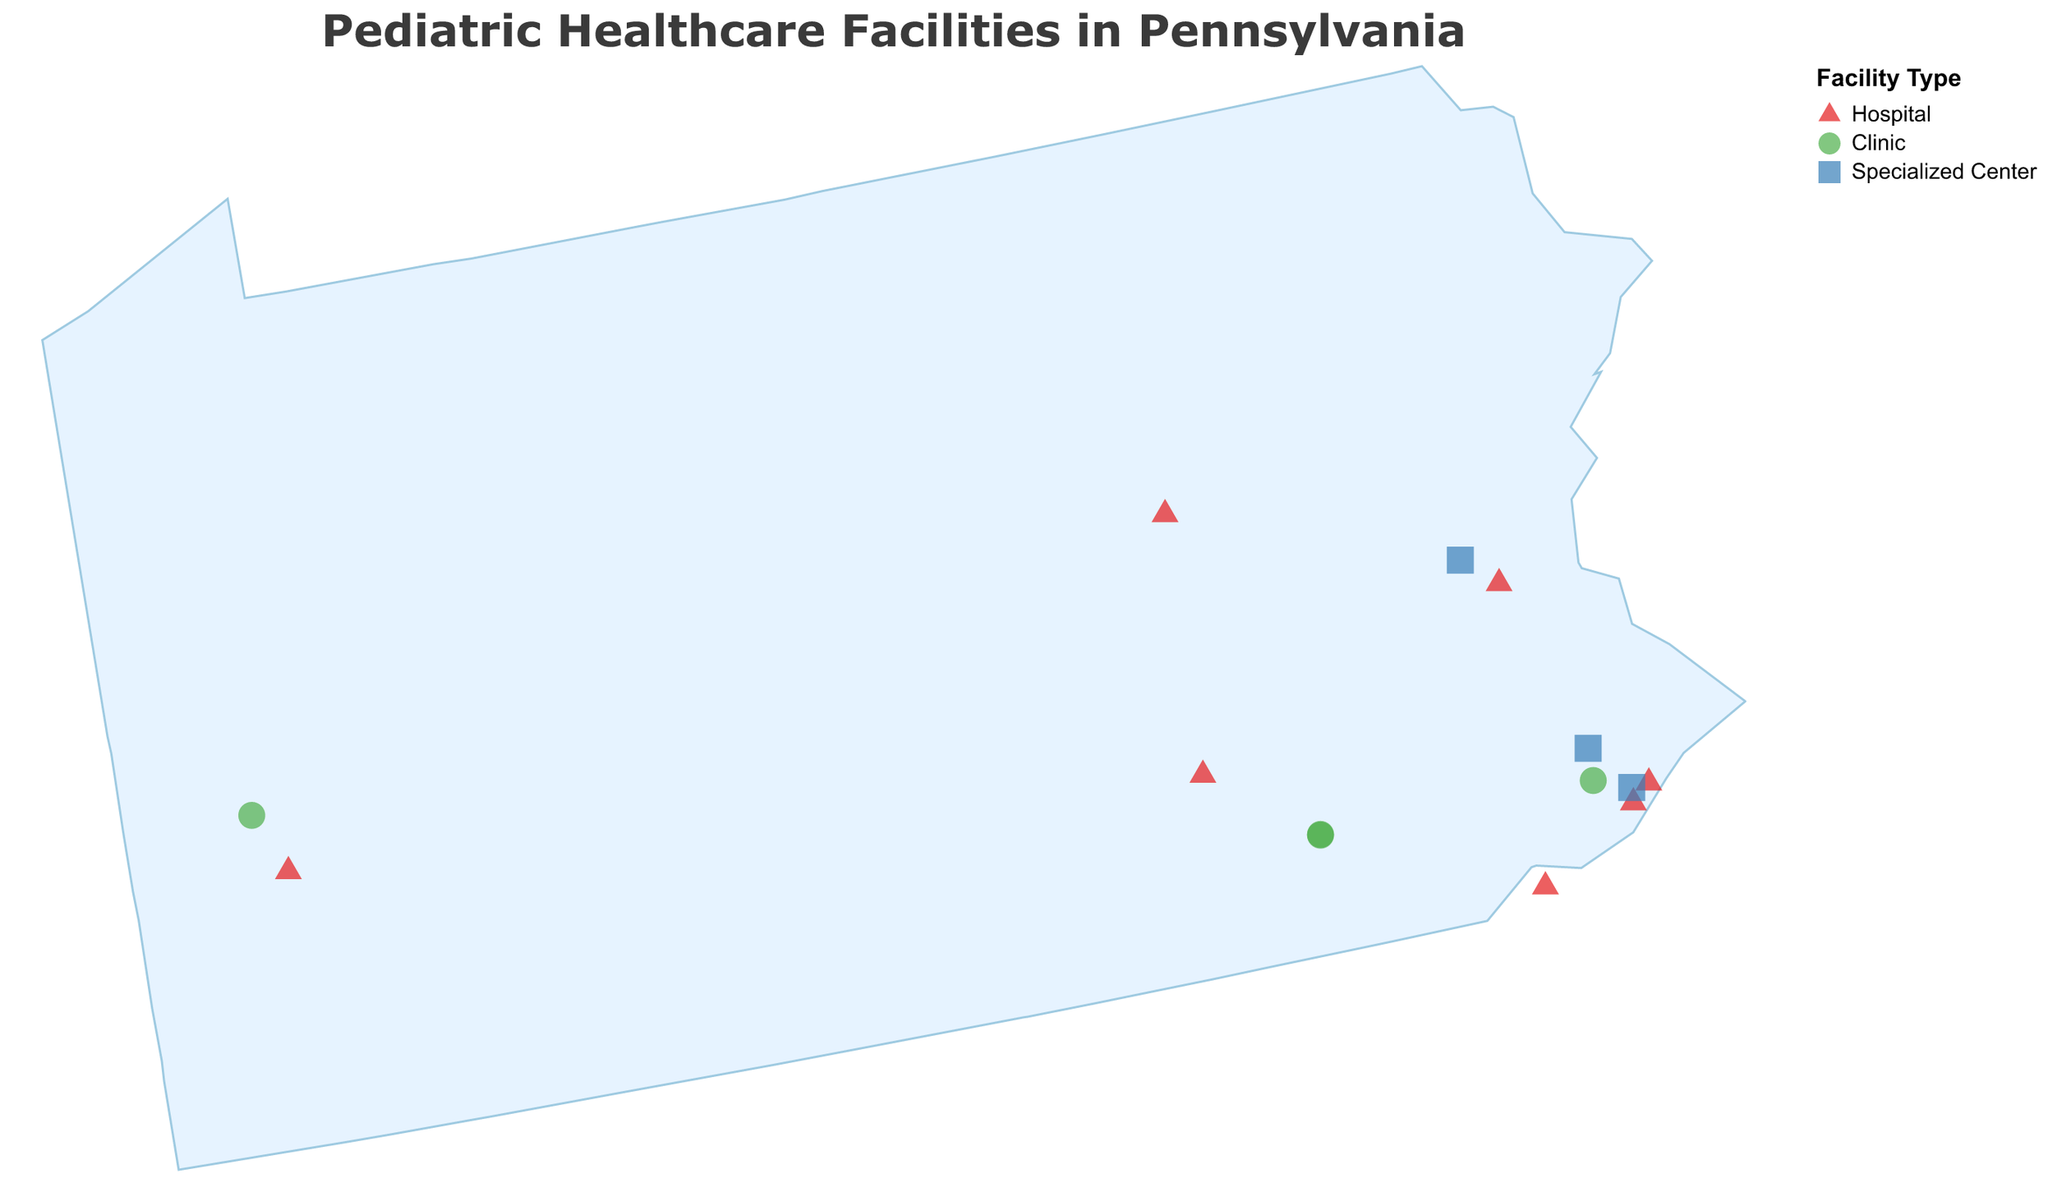How many different types of pediatric healthcare facilities are shown in the plot? The plot legend shows three different facility types: Hospital, Clinic, and Specialized Center.
Answer: 3 What is the most common specialty among the facilities in the plot? By looking at the tooltip or dataset, we see that "Comprehensive" is the most frequent specialty listed among hospitals and other facilities.
Answer: Comprehensive Which type of facility is the closest to Philadelphia? By observing the geographic distribution of points, "Children's Hospital of Philadelphia" and "Shriners Hospitals for Children - Philadelphia" are both near Philadelphia, but the former is exactly in Philadelphia.
Answer: Children's Hospital of Philadelphia Compare the number of clinics to specialized centers. Which is greater? By counting points based on the shape and legend, there are 5 clinics (circles) and 3 specialized centers (squares), so clinics are greater.
Answer: Clinics What is the specialty of Geisinger Janet Weis Children's Hospital? By referring to the tooltips or dataset, Geisinger Janet Weis Children's Hospital specializes in "Comprehensive" care.
Answer: Comprehensive Which area (East or West Pennsylvania) has more comprehensive children's hospitals? Count and compare the number of comprehensive hospitals on both sides of the state. The east side has three (Children's Hospital of Philadelphia, St. Christopher's Hospital, Nemours/Alfred I. duPont Hospital), while the west side has one (UPMC Children’s Hospital of Pittsburgh).
Answer: East Pennsylvania How many specialized centers focus on multispecialty care? By referring to the tooltips or dataset, the specialized centers focusing on multispecialty are the Children’s Hospital of Philadelphia Specialty Care Center and Pediatric Specialty Care at Lehigh Valley Hospital.
Answer: 2 Are there any pediatric healthcare facilities in Lancaster, PA? If so, what type and specialty? Observing the plot, there are two clinics located in Lancaster, PA: Penn State Health Children's Lancaster Pediatric Center and Penn Medicine Lancaster General Health Suburban Pediatrics, both specializing in General Pediatrics.
Answer: Yes, two clinics with General Pediatrics Identify the hospital located furthest to the north. The northernmost hospital based on the latitude is Geisinger Janet Weis Children's Hospital.
Answer: Geisinger Janet Weis Children's Hospital Which hospital provides general pediatrics care and where is it located? Lehigh Valley Reilly Children's Hospital specializes in General Pediatrics and is located in Lehigh Valley (Latitude: 40.5995, Longitude: -75.4926).
Answer: Lehigh Valley Reilly Children's Hospital 